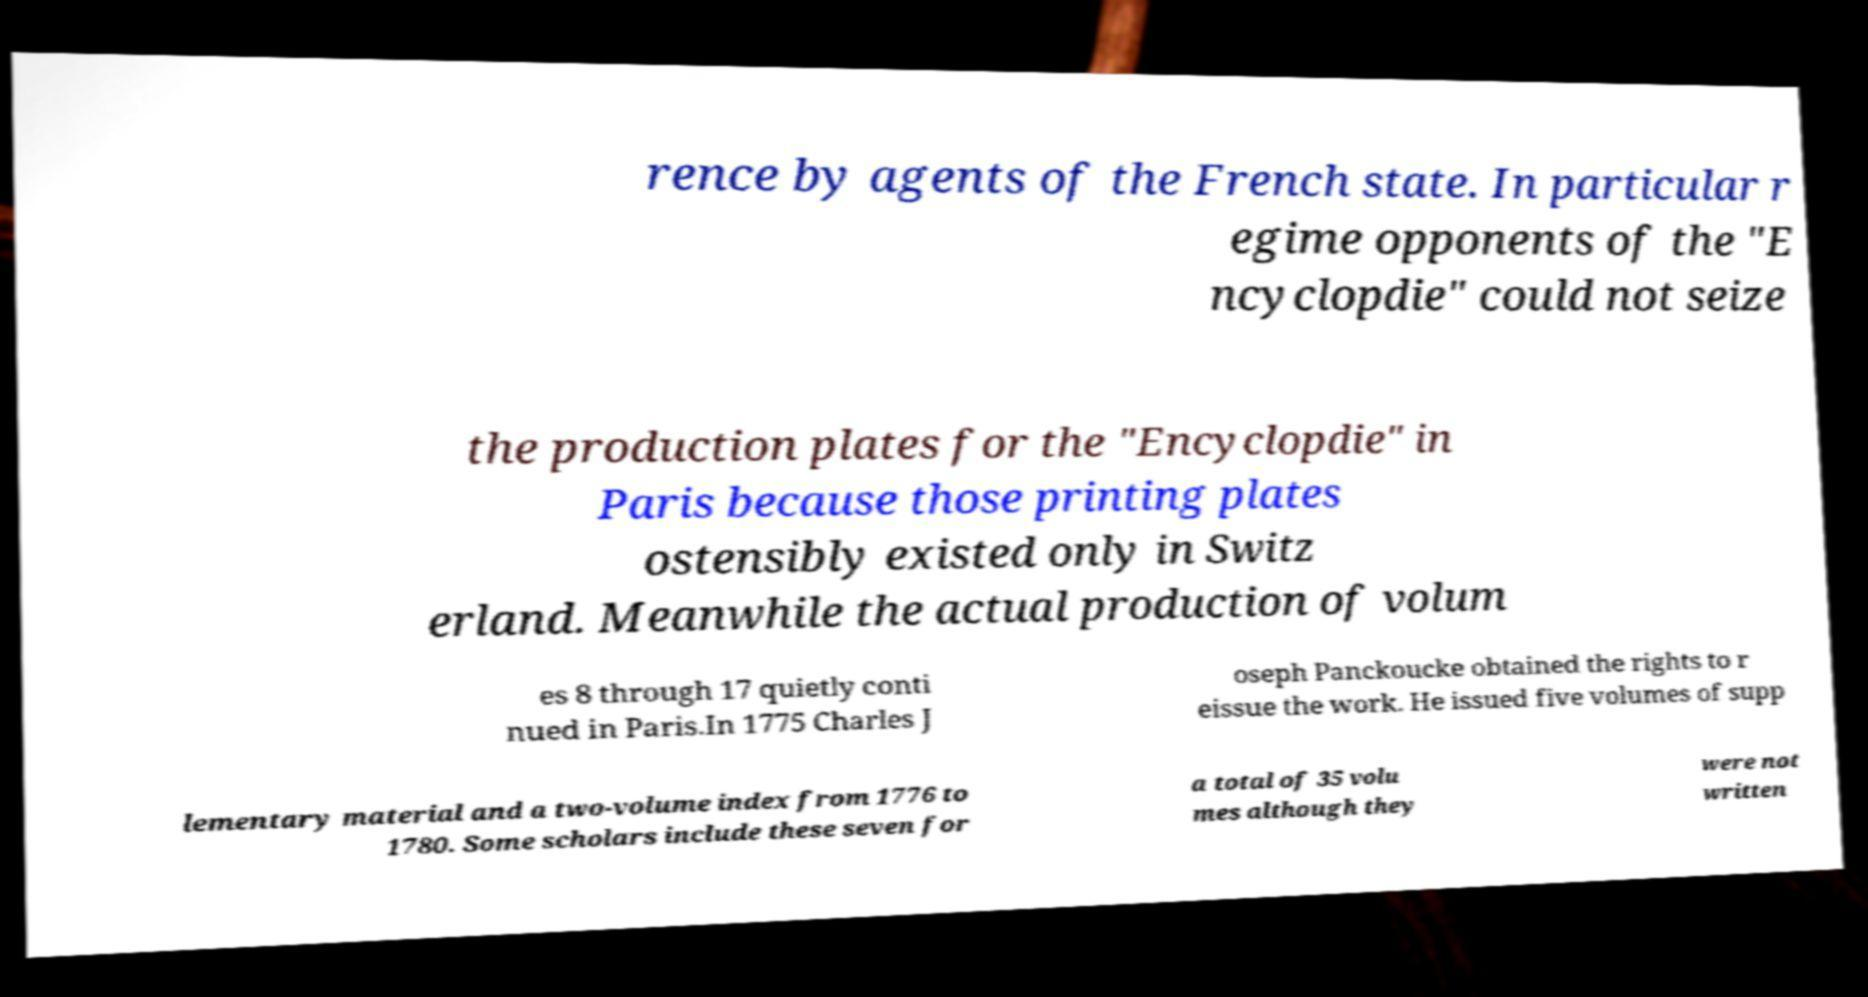Could you assist in decoding the text presented in this image and type it out clearly? rence by agents of the French state. In particular r egime opponents of the "E ncyclopdie" could not seize the production plates for the "Encyclopdie" in Paris because those printing plates ostensibly existed only in Switz erland. Meanwhile the actual production of volum es 8 through 17 quietly conti nued in Paris.In 1775 Charles J oseph Panckoucke obtained the rights to r eissue the work. He issued five volumes of supp lementary material and a two-volume index from 1776 to 1780. Some scholars include these seven for a total of 35 volu mes although they were not written 